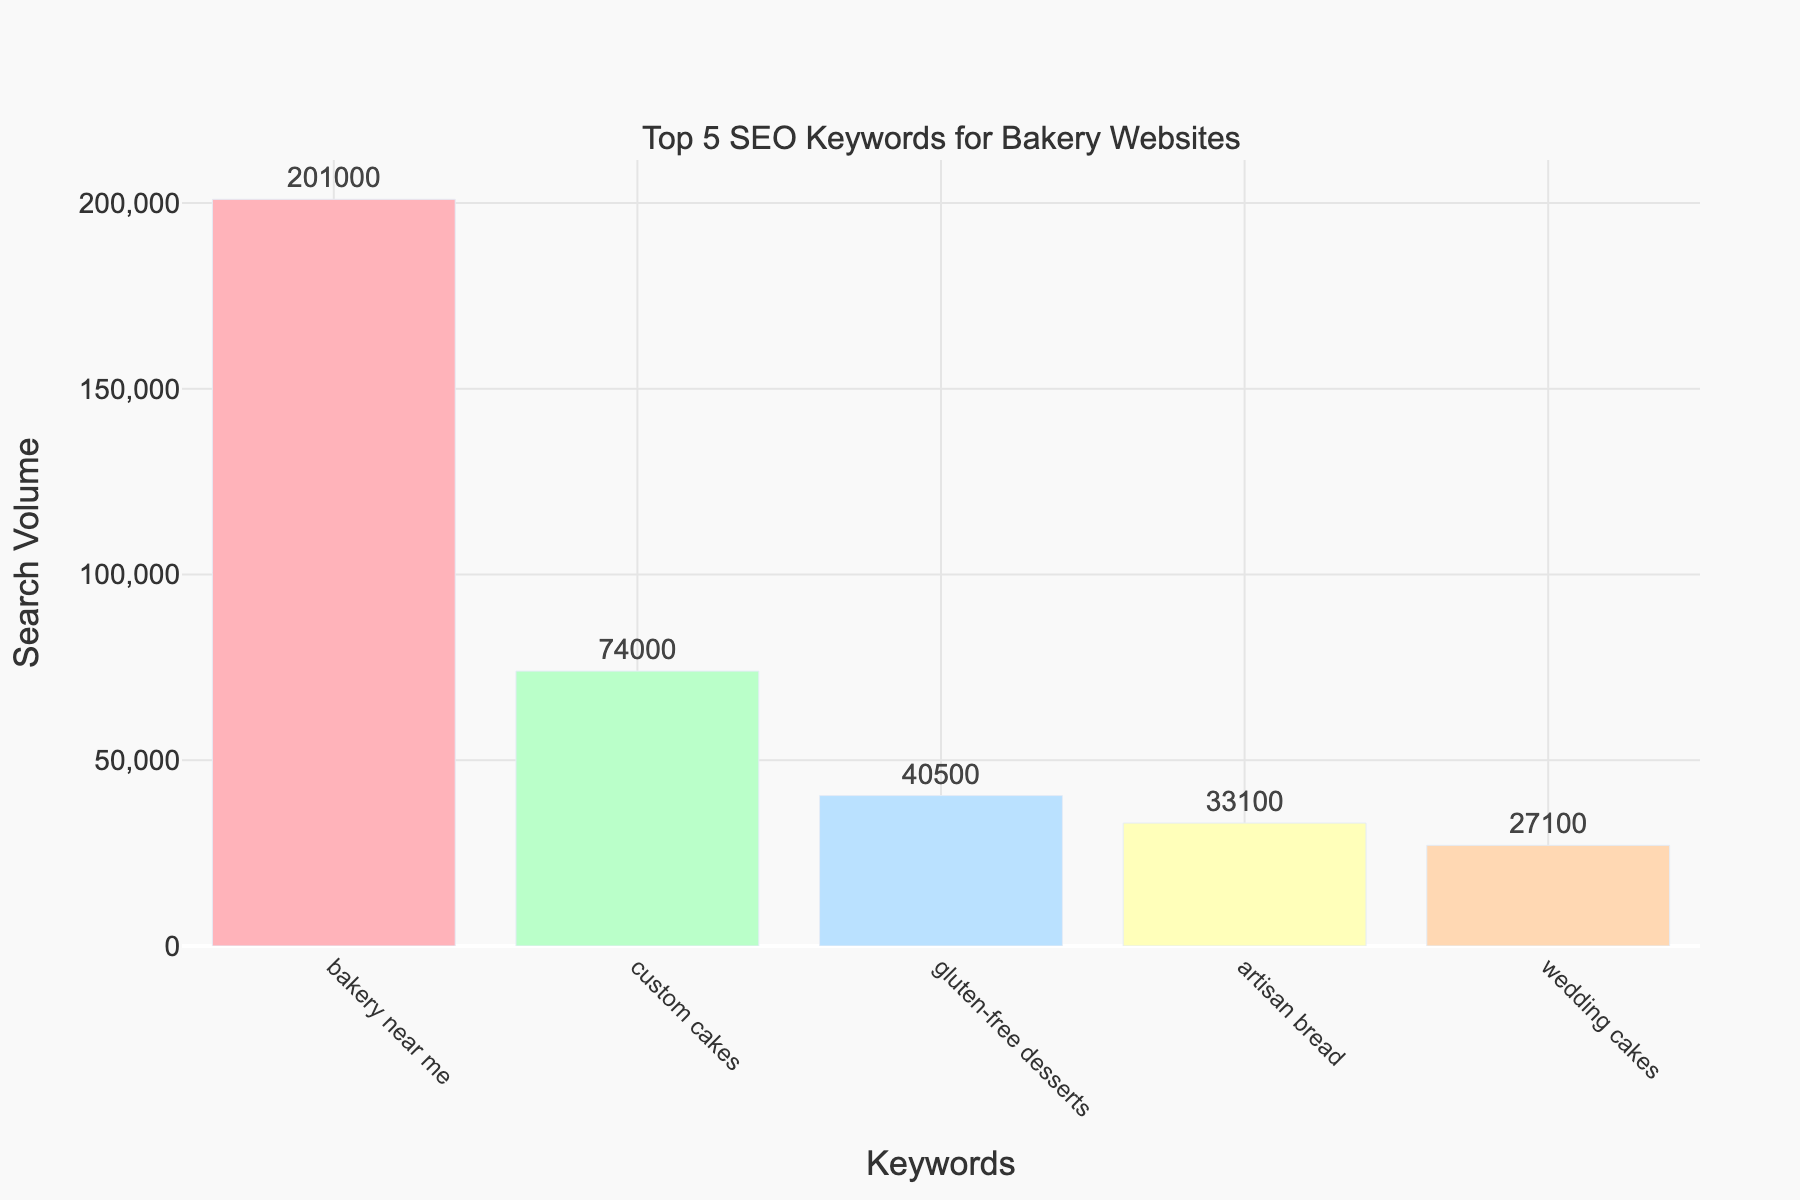what are the Top 5 SEO keywords for bakery websites? The figure shows five keywords with their respective search volumes, listed in order from highest to lowest. The keywords are "bakery near me," "custom cakes," "gluten-free desserts," "artisan bread," and "wedding cakes."
Answer: bakery near me, custom cakes, gluten-free desserts, artisan bread, wedding cakes Which keyword has the highest search volume? By looking at the chart, the keyword with the tallest bar is "bakery near me," indicating it has the highest search volume.
Answer: bakery near me What is the total search volume of the top 5 SEO keywords combined? We sum the search volumes of all five keywords: 201,000 (bakery near me) + 74,000 (custom cakes) + 40,500 (gluten-free desserts) + 33,100 (artisan bread) + 27,100 (wedding cakes) = 375,700.
Answer: 375,700 How much higher is the search volume for "bakery near me" compared to "wedding cakes"? Subtract the search volume of "wedding cakes" from "bakery near me": 201,000 - 27,100 = 173,900.
Answer: 173,900 Which keyword has the lowest search volume? The shortest bar in the chart represents "wedding cakes," so it has the lowest search volume.
Answer: wedding cakes What is the average search volume of the top 5 SEO keywords? To find the average, sum all the search volumes and divide by 5: (201,000 + 74,000 + 40,500 + 33,100 + 27,100) / 5 = 375,700 / 5 = 75,140.
Answer: 75,140 How many keywords have a search volume higher than 50,000? By looking at the heights of the bars, we see two keywords with search volumes higher than 50,000: "bakery near me" and "custom cakes."
Answer: 2 What color represents the keyword "artisan bread"? From the chart, "artisan bread" is associated with the color yellow.
Answer: yellow 